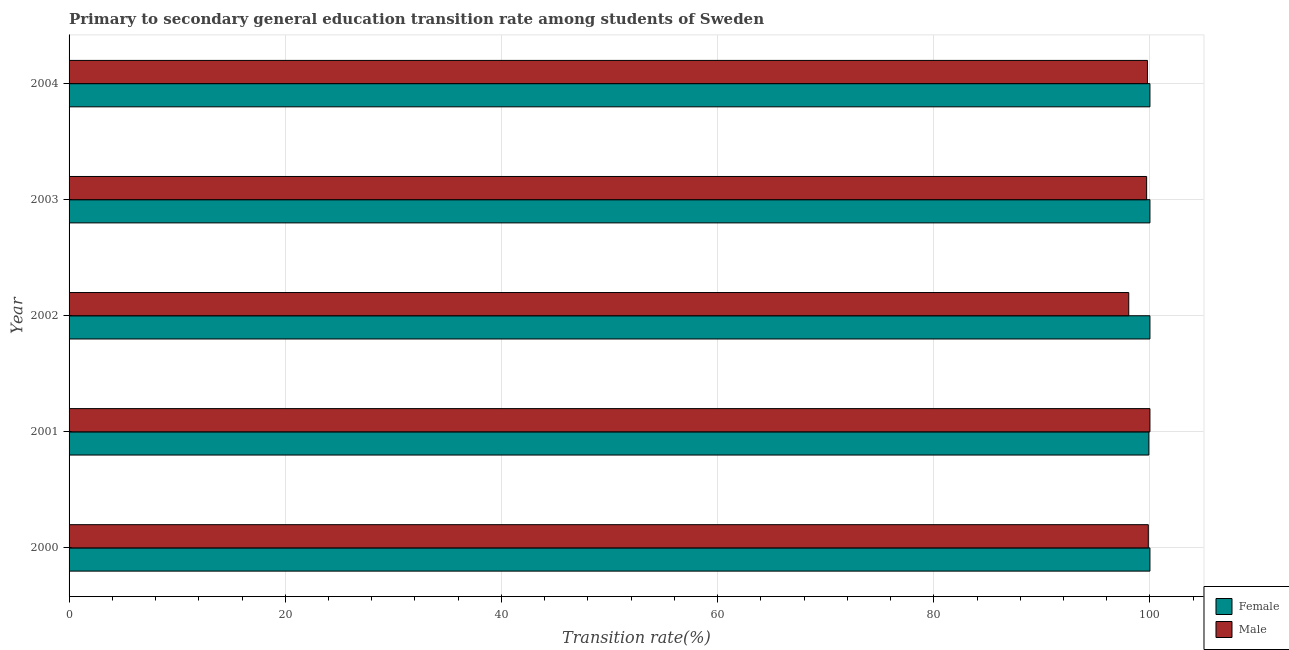Are the number of bars per tick equal to the number of legend labels?
Your response must be concise. Yes. Are the number of bars on each tick of the Y-axis equal?
Offer a very short reply. Yes. What is the label of the 2nd group of bars from the top?
Offer a terse response. 2003. What is the transition rate among male students in 2003?
Your answer should be compact. 99.7. Across all years, what is the minimum transition rate among female students?
Offer a terse response. 99.9. In which year was the transition rate among female students maximum?
Make the answer very short. 2000. In which year was the transition rate among male students minimum?
Give a very brief answer. 2002. What is the total transition rate among male students in the graph?
Offer a terse response. 497.36. What is the difference between the transition rate among female students in 2000 and that in 2001?
Make the answer very short. 0.1. What is the average transition rate among male students per year?
Keep it short and to the point. 99.47. In the year 2003, what is the difference between the transition rate among female students and transition rate among male students?
Your answer should be very brief. 0.3. In how many years, is the transition rate among male students greater than 40 %?
Offer a very short reply. 5. What is the ratio of the transition rate among female students in 2000 to that in 2002?
Keep it short and to the point. 1. Is the difference between the transition rate among male students in 2000 and 2001 greater than the difference between the transition rate among female students in 2000 and 2001?
Give a very brief answer. No. What is the difference between the highest and the lowest transition rate among male students?
Your answer should be very brief. 1.96. What does the 1st bar from the bottom in 2003 represents?
Your answer should be compact. Female. Are all the bars in the graph horizontal?
Offer a terse response. Yes. How many years are there in the graph?
Your response must be concise. 5. Where does the legend appear in the graph?
Provide a short and direct response. Bottom right. How are the legend labels stacked?
Provide a succinct answer. Vertical. What is the title of the graph?
Keep it short and to the point. Primary to secondary general education transition rate among students of Sweden. What is the label or title of the X-axis?
Offer a terse response. Transition rate(%). What is the label or title of the Y-axis?
Make the answer very short. Year. What is the Transition rate(%) of Female in 2000?
Keep it short and to the point. 100. What is the Transition rate(%) in Male in 2000?
Ensure brevity in your answer.  99.85. What is the Transition rate(%) of Female in 2001?
Offer a very short reply. 99.9. What is the Transition rate(%) in Male in 2001?
Ensure brevity in your answer.  100. What is the Transition rate(%) of Male in 2002?
Provide a short and direct response. 98.04. What is the Transition rate(%) of Female in 2003?
Offer a very short reply. 100. What is the Transition rate(%) in Male in 2003?
Your response must be concise. 99.7. What is the Transition rate(%) in Male in 2004?
Ensure brevity in your answer.  99.77. Across all years, what is the maximum Transition rate(%) in Female?
Make the answer very short. 100. Across all years, what is the maximum Transition rate(%) in Male?
Make the answer very short. 100. Across all years, what is the minimum Transition rate(%) in Female?
Your answer should be very brief. 99.9. Across all years, what is the minimum Transition rate(%) of Male?
Your response must be concise. 98.04. What is the total Transition rate(%) of Female in the graph?
Offer a terse response. 499.9. What is the total Transition rate(%) of Male in the graph?
Your response must be concise. 497.36. What is the difference between the Transition rate(%) in Female in 2000 and that in 2001?
Provide a short and direct response. 0.1. What is the difference between the Transition rate(%) in Male in 2000 and that in 2001?
Your answer should be compact. -0.15. What is the difference between the Transition rate(%) in Male in 2000 and that in 2002?
Your answer should be very brief. 1.81. What is the difference between the Transition rate(%) of Female in 2000 and that in 2003?
Offer a terse response. 0. What is the difference between the Transition rate(%) of Male in 2000 and that in 2003?
Your answer should be very brief. 0.16. What is the difference between the Transition rate(%) in Male in 2000 and that in 2004?
Offer a very short reply. 0.08. What is the difference between the Transition rate(%) in Male in 2001 and that in 2002?
Offer a terse response. 1.96. What is the difference between the Transition rate(%) of Female in 2001 and that in 2003?
Keep it short and to the point. -0.1. What is the difference between the Transition rate(%) of Male in 2001 and that in 2003?
Your answer should be very brief. 0.3. What is the difference between the Transition rate(%) in Female in 2001 and that in 2004?
Give a very brief answer. -0.1. What is the difference between the Transition rate(%) of Male in 2001 and that in 2004?
Provide a short and direct response. 0.23. What is the difference between the Transition rate(%) in Male in 2002 and that in 2003?
Offer a very short reply. -1.65. What is the difference between the Transition rate(%) of Male in 2002 and that in 2004?
Keep it short and to the point. -1.73. What is the difference between the Transition rate(%) in Female in 2003 and that in 2004?
Your answer should be compact. 0. What is the difference between the Transition rate(%) in Male in 2003 and that in 2004?
Keep it short and to the point. -0.08. What is the difference between the Transition rate(%) in Female in 2000 and the Transition rate(%) in Male in 2001?
Make the answer very short. 0. What is the difference between the Transition rate(%) of Female in 2000 and the Transition rate(%) of Male in 2002?
Make the answer very short. 1.96. What is the difference between the Transition rate(%) in Female in 2000 and the Transition rate(%) in Male in 2003?
Keep it short and to the point. 0.3. What is the difference between the Transition rate(%) in Female in 2000 and the Transition rate(%) in Male in 2004?
Your answer should be compact. 0.23. What is the difference between the Transition rate(%) in Female in 2001 and the Transition rate(%) in Male in 2002?
Ensure brevity in your answer.  1.86. What is the difference between the Transition rate(%) of Female in 2001 and the Transition rate(%) of Male in 2003?
Your response must be concise. 0.2. What is the difference between the Transition rate(%) of Female in 2001 and the Transition rate(%) of Male in 2004?
Provide a short and direct response. 0.13. What is the difference between the Transition rate(%) of Female in 2002 and the Transition rate(%) of Male in 2003?
Offer a very short reply. 0.3. What is the difference between the Transition rate(%) in Female in 2002 and the Transition rate(%) in Male in 2004?
Make the answer very short. 0.23. What is the difference between the Transition rate(%) of Female in 2003 and the Transition rate(%) of Male in 2004?
Ensure brevity in your answer.  0.23. What is the average Transition rate(%) of Female per year?
Offer a very short reply. 99.98. What is the average Transition rate(%) of Male per year?
Make the answer very short. 99.47. In the year 2000, what is the difference between the Transition rate(%) of Female and Transition rate(%) of Male?
Offer a terse response. 0.15. In the year 2002, what is the difference between the Transition rate(%) in Female and Transition rate(%) in Male?
Your answer should be very brief. 1.96. In the year 2003, what is the difference between the Transition rate(%) in Female and Transition rate(%) in Male?
Your answer should be compact. 0.3. In the year 2004, what is the difference between the Transition rate(%) in Female and Transition rate(%) in Male?
Make the answer very short. 0.23. What is the ratio of the Transition rate(%) in Female in 2000 to that in 2001?
Keep it short and to the point. 1. What is the ratio of the Transition rate(%) in Male in 2000 to that in 2001?
Ensure brevity in your answer.  1. What is the ratio of the Transition rate(%) of Female in 2000 to that in 2002?
Offer a terse response. 1. What is the ratio of the Transition rate(%) in Male in 2000 to that in 2002?
Your answer should be very brief. 1.02. What is the ratio of the Transition rate(%) of Female in 2000 to that in 2003?
Provide a short and direct response. 1. What is the ratio of the Transition rate(%) in Female in 2000 to that in 2004?
Offer a terse response. 1. What is the ratio of the Transition rate(%) of Male in 2000 to that in 2004?
Offer a very short reply. 1. What is the ratio of the Transition rate(%) in Male in 2001 to that in 2003?
Offer a terse response. 1. What is the ratio of the Transition rate(%) of Female in 2001 to that in 2004?
Offer a very short reply. 1. What is the ratio of the Transition rate(%) in Female in 2002 to that in 2003?
Make the answer very short. 1. What is the ratio of the Transition rate(%) in Male in 2002 to that in 2003?
Give a very brief answer. 0.98. What is the ratio of the Transition rate(%) of Female in 2002 to that in 2004?
Provide a short and direct response. 1. What is the ratio of the Transition rate(%) of Male in 2002 to that in 2004?
Offer a terse response. 0.98. What is the ratio of the Transition rate(%) in Male in 2003 to that in 2004?
Make the answer very short. 1. What is the difference between the highest and the second highest Transition rate(%) in Male?
Your answer should be compact. 0.15. What is the difference between the highest and the lowest Transition rate(%) in Female?
Ensure brevity in your answer.  0.1. What is the difference between the highest and the lowest Transition rate(%) of Male?
Ensure brevity in your answer.  1.96. 